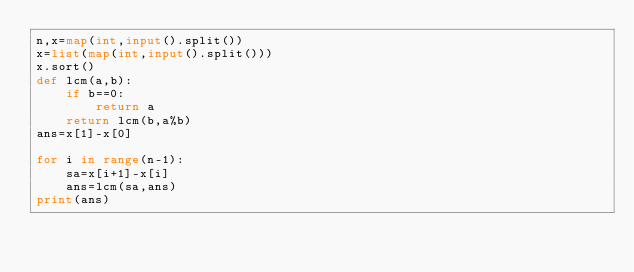Convert code to text. <code><loc_0><loc_0><loc_500><loc_500><_Python_>n,x=map(int,input().split())
x=list(map(int,input().split()))
x.sort()
def lcm(a,b):
    if b==0:
        return a 
    return lcm(b,a%b)
ans=x[1]-x[0]

for i in range(n-1):
    sa=x[i+1]-x[i]
    ans=lcm(sa,ans)
print(ans)

</code> 